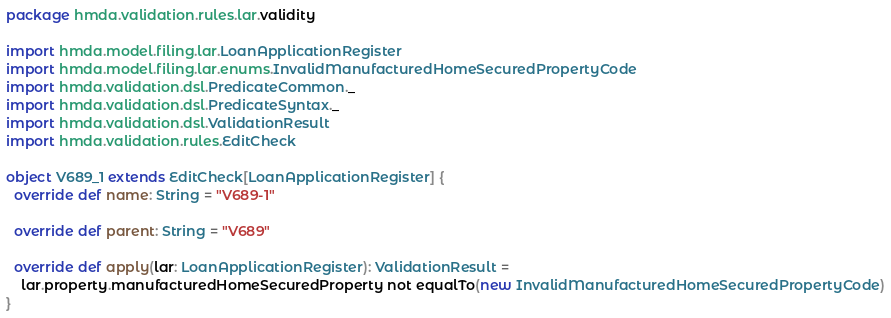<code> <loc_0><loc_0><loc_500><loc_500><_Scala_>package hmda.validation.rules.lar.validity

import hmda.model.filing.lar.LoanApplicationRegister
import hmda.model.filing.lar.enums.InvalidManufacturedHomeSecuredPropertyCode
import hmda.validation.dsl.PredicateCommon._
import hmda.validation.dsl.PredicateSyntax._
import hmda.validation.dsl.ValidationResult
import hmda.validation.rules.EditCheck

object V689_1 extends EditCheck[LoanApplicationRegister] {
  override def name: String = "V689-1"

  override def parent: String = "V689"

  override def apply(lar: LoanApplicationRegister): ValidationResult =
    lar.property.manufacturedHomeSecuredProperty not equalTo(new InvalidManufacturedHomeSecuredPropertyCode)
}
</code> 